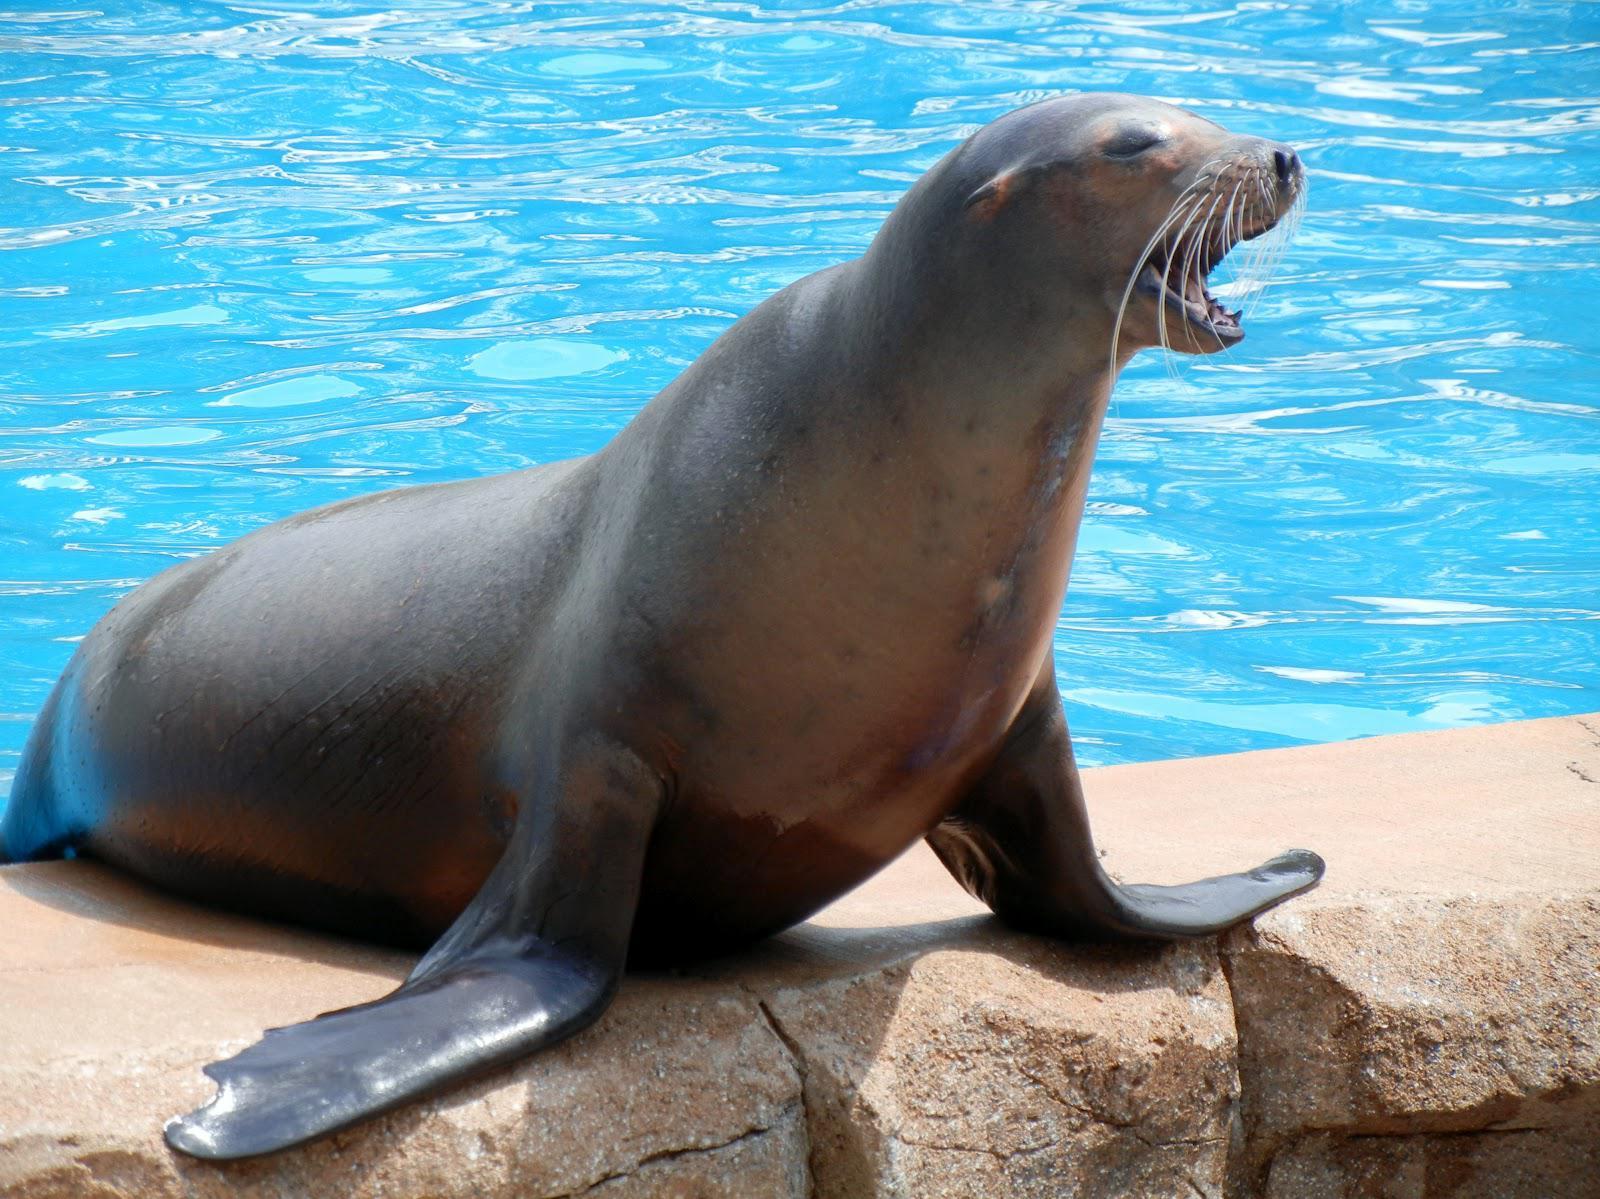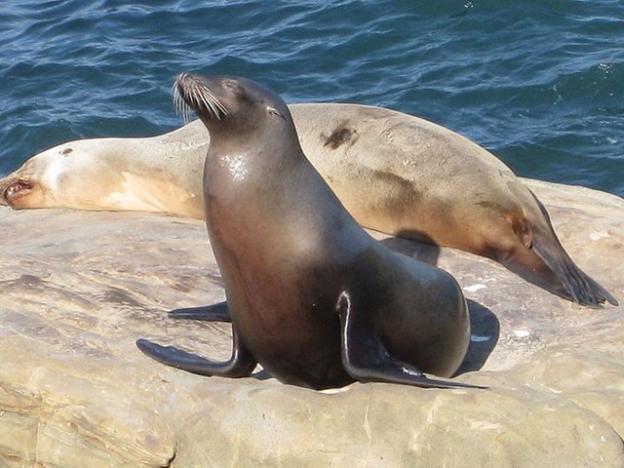The first image is the image on the left, the second image is the image on the right. For the images displayed, is the sentence "At least one of the seals is in the water." factually correct? Answer yes or no. No. The first image is the image on the left, the second image is the image on the right. Considering the images on both sides, is "An image includes one reclining seal next to a seal with raised head and shoulders." valid? Answer yes or no. Yes. 